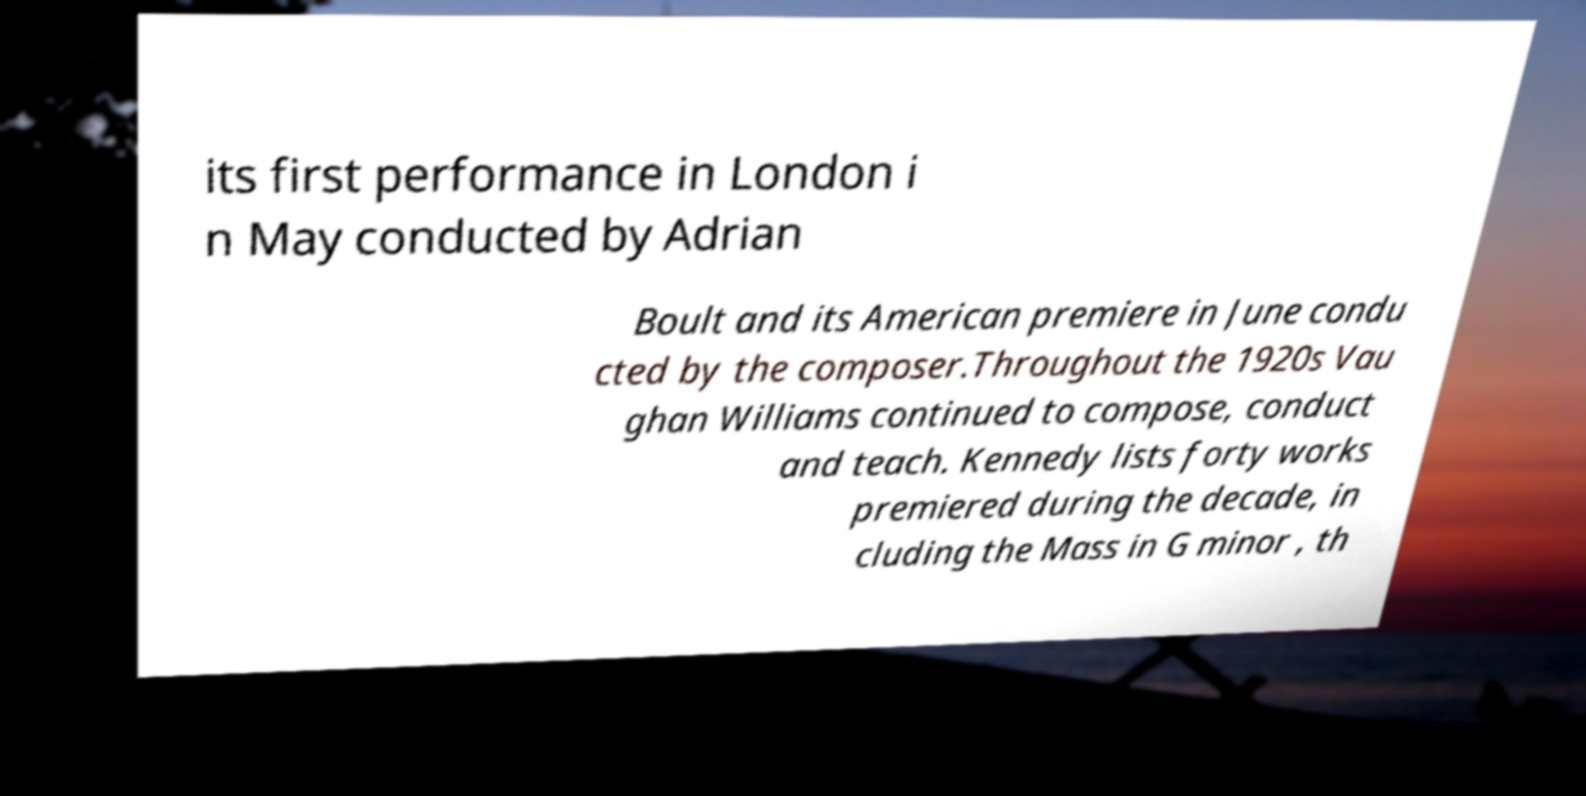Please identify and transcribe the text found in this image. its first performance in London i n May conducted by Adrian Boult and its American premiere in June condu cted by the composer.Throughout the 1920s Vau ghan Williams continued to compose, conduct and teach. Kennedy lists forty works premiered during the decade, in cluding the Mass in G minor , th 